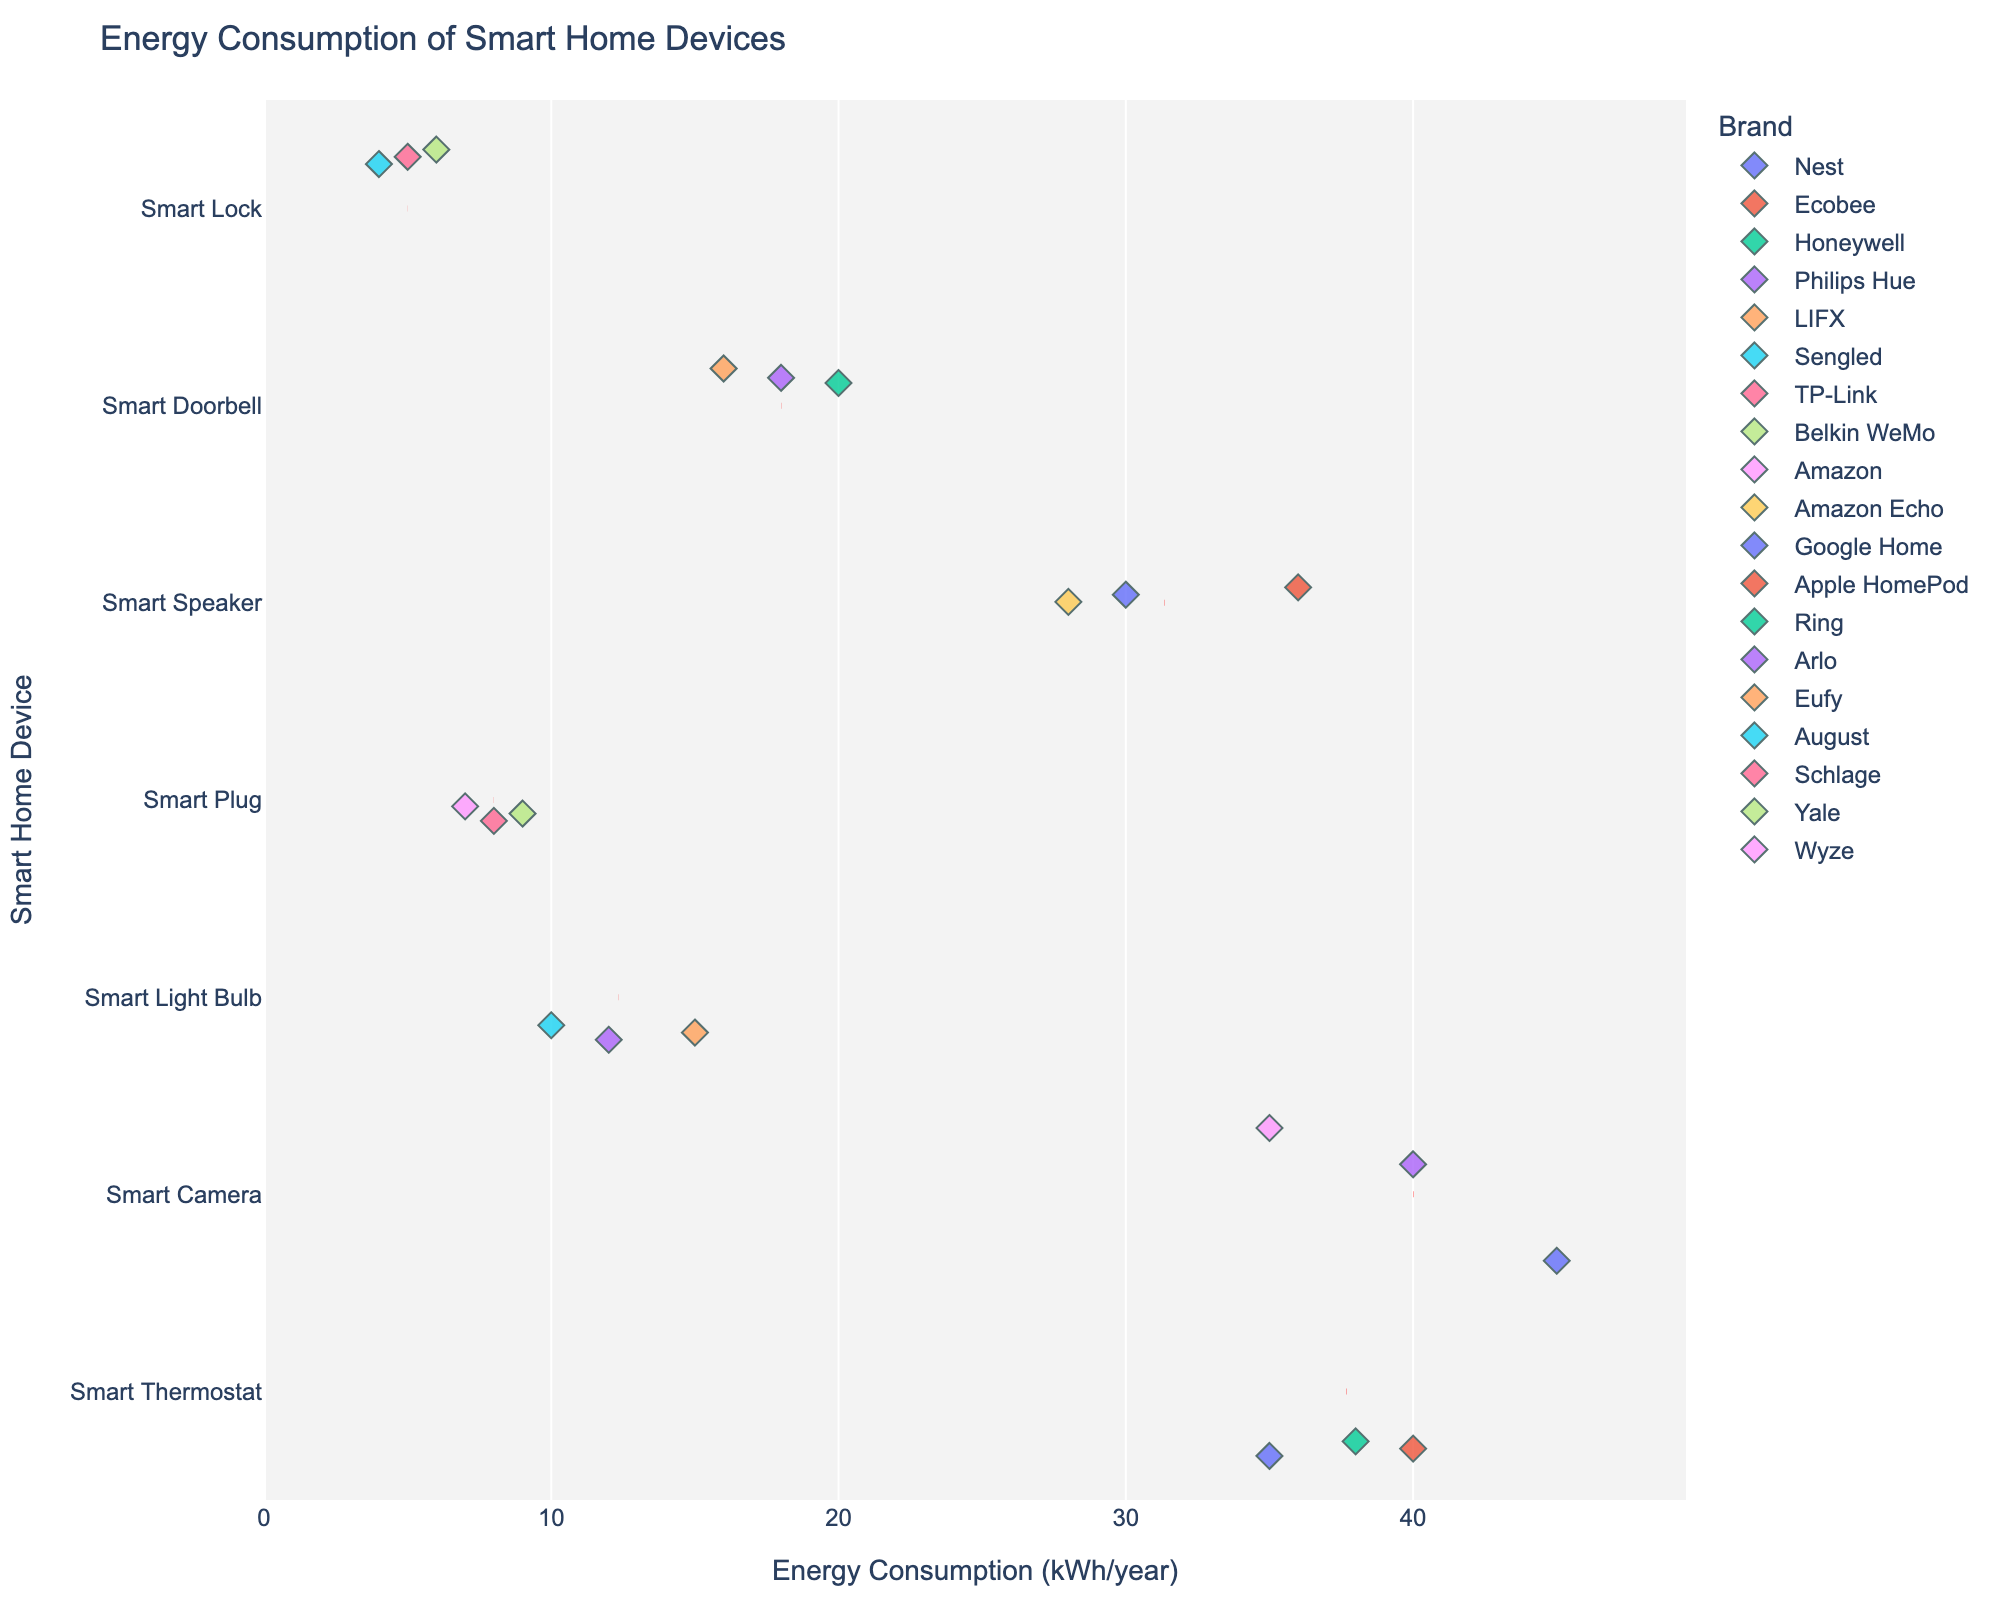What's the title of the figure? The title of the figure is located at the top and denotes what the overall plot is about.
Answer: Energy Consumption of Smart Home Devices What is the range of energy consumption values shown on the x-axis? The x-axis displays the range of energy consumption values from the minimum to slightly above the maximum value in the dataset.
Answer: 0 to around 50 kWh/year Which device type has the highest individual energy consumption value and what is that value? By visually inspecting the rightmost points along the x-axis, the device type with the highest energy consumption can be identified. The highest value is for Smart Camera.
Answer: Smart Camera, 45 kWh/year On average, which brand's smart light bulbs consume the most energy? Observe the distribution of energy consumption values for lines corresponding to each Smart Light Bulb brand and compare average positions. Use the red mean lines for accurate average comparison.
Answer: LIFX Which smart home device has the lowest average energy consumption and what is that value? Look at the red dashed median lines for each device and identify the one with the lowest horizontal position.
Answer: Smart Plug, around 8 kWh/year What is the difference in energy consumption between the most and least consuming smart speakers? Identify the smart speakers on the plot and compare the highest and lowest points, then calculate the difference in their energy consumptions.
Answer: 36 - 28 = 8 kWh/year Are there any smart doorbells that consume less than 20 kWh/year? If so, which brands? Inspect the Smart Doorbell data points aligned vertically and look for those below the 20 kWh/year mark. Identify the corresponding brands.
Answer: Yes, Arlo and Eufy What are the mean energy consumption values for smart thermostats and smart cameras? Identify the red dashed mean lines for both Smart Thermostat and Smart Camera and note their positions on the x-axis.
Answer: Smart Thermostat: around 38 kWh/year, Smart Camera: around 40 kWh/year How many data points are there for smart plugs? Each data point represents an energy consumption value, so count the markers aligned with the Smart Plug label.
Answer: Three Do any brands appear multiple times across different device types? Provide an example. Look for brand names that occur in more than one vertical line (device type) on the plot.
Answer: Amazon (Smart Plug, Smart Speaker, Smart Camera) 